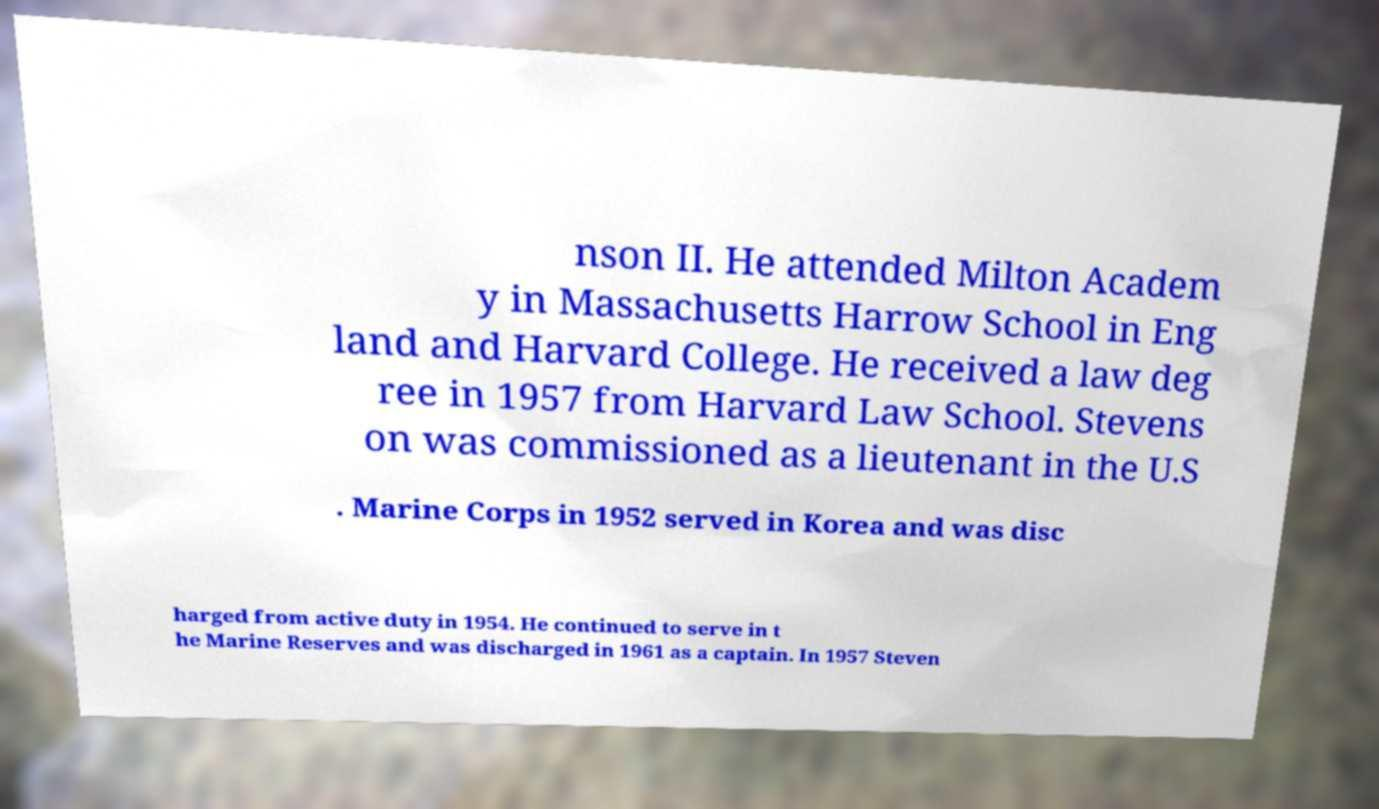I need the written content from this picture converted into text. Can you do that? nson II. He attended Milton Academ y in Massachusetts Harrow School in Eng land and Harvard College. He received a law deg ree in 1957 from Harvard Law School. Stevens on was commissioned as a lieutenant in the U.S . Marine Corps in 1952 served in Korea and was disc harged from active duty in 1954. He continued to serve in t he Marine Reserves and was discharged in 1961 as a captain. In 1957 Steven 